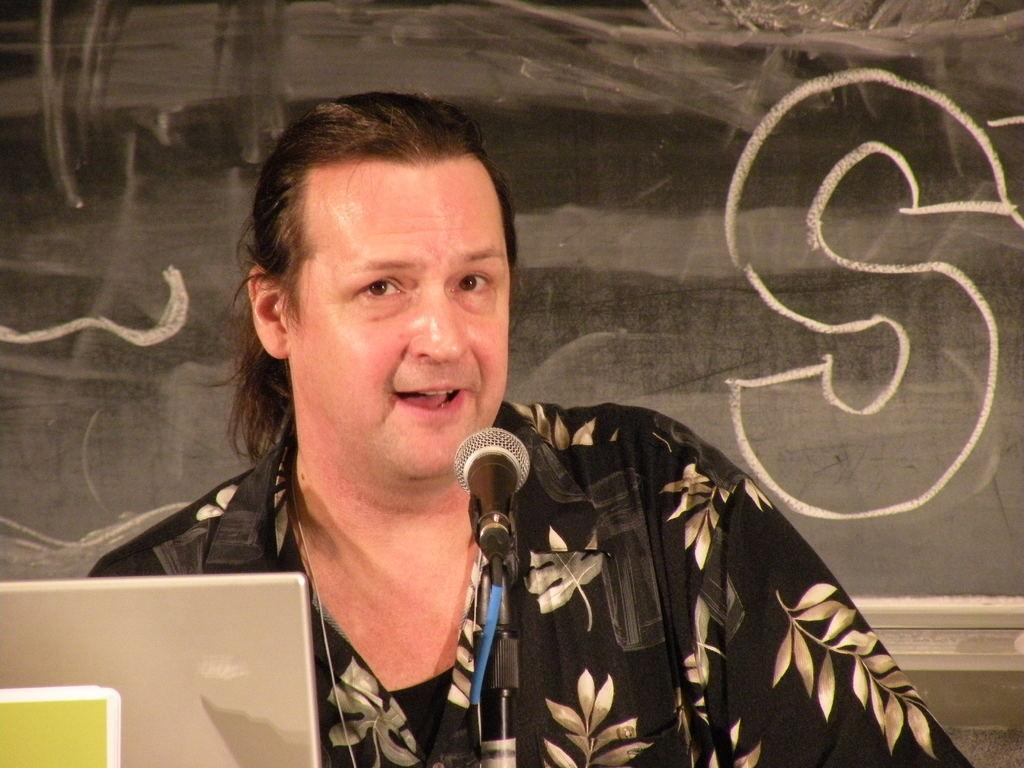Who is the main subject in the image? There is a man in the image. What is the man wearing? The man is wearing a black color shirt. What is the man doing in the image? The man is giving a speech. What tool is the man using to amplify his voice? The man is using a microphone. What electronic device can be seen in the image? There is a silver color laptop in the image. What color is the board visible in the background? There is a black color board in the background of the image. What type of map can be seen on the black color board in the image? There is no map present on the black color board in the image. What country is the man representing in his speech? The image does not provide information about the man's nationality or the country he might be representing. 